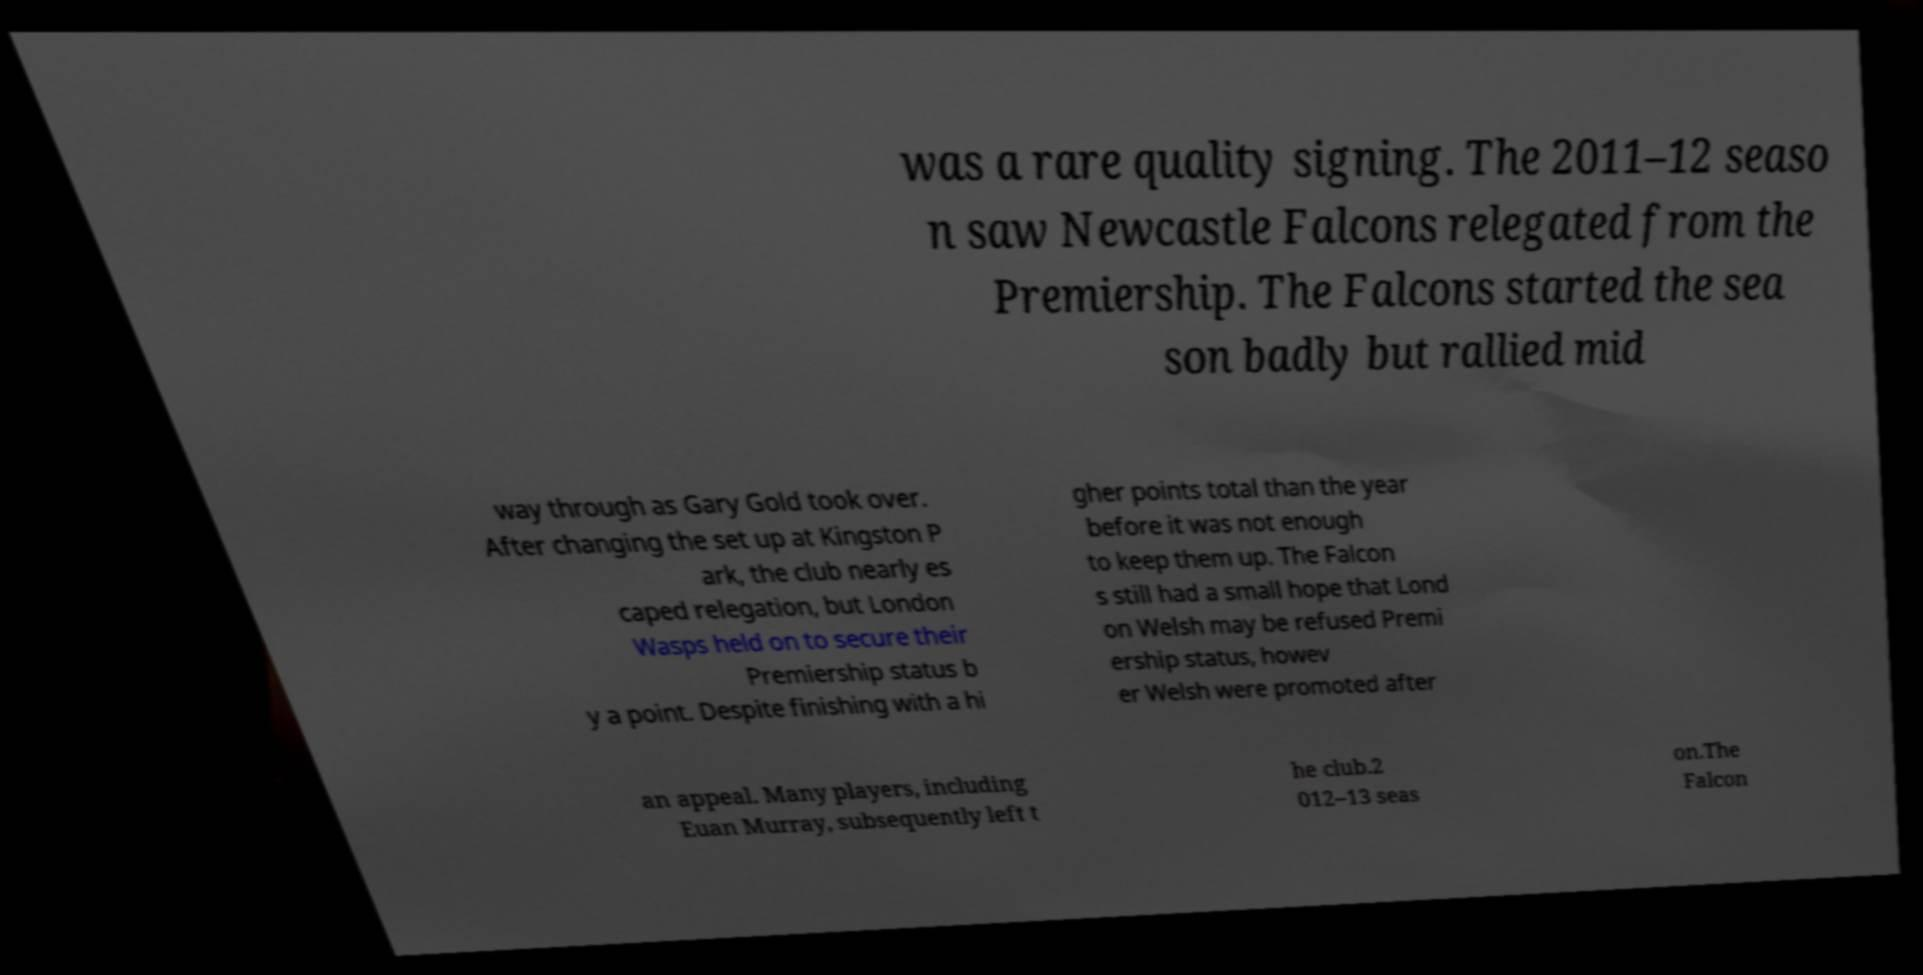Please read and relay the text visible in this image. What does it say? was a rare quality signing. The 2011–12 seaso n saw Newcastle Falcons relegated from the Premiership. The Falcons started the sea son badly but rallied mid way through as Gary Gold took over. After changing the set up at Kingston P ark, the club nearly es caped relegation, but London Wasps held on to secure their Premiership status b y a point. Despite finishing with a hi gher points total than the year before it was not enough to keep them up. The Falcon s still had a small hope that Lond on Welsh may be refused Premi ership status, howev er Welsh were promoted after an appeal. Many players, including Euan Murray, subsequently left t he club.2 012–13 seas on.The Falcon 